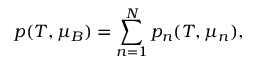<formula> <loc_0><loc_0><loc_500><loc_500>p ( T , \mu _ { B } ) = \sum _ { n = 1 } ^ { N } p _ { n } ( T , \mu _ { n } ) ,</formula> 